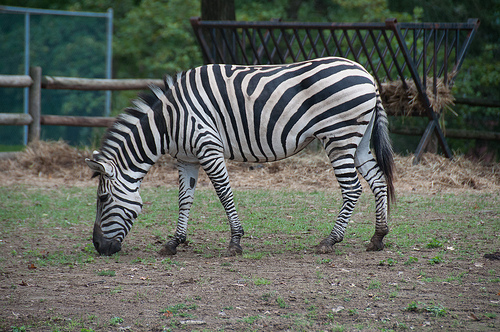Please provide the bounding box coordinate of the region this sentence describes: tail on a zebra. The tail of the zebra can be outlined by the coordinates [0.73, 0.34, 0.82, 0.63], located towards the lower right section of the image. 